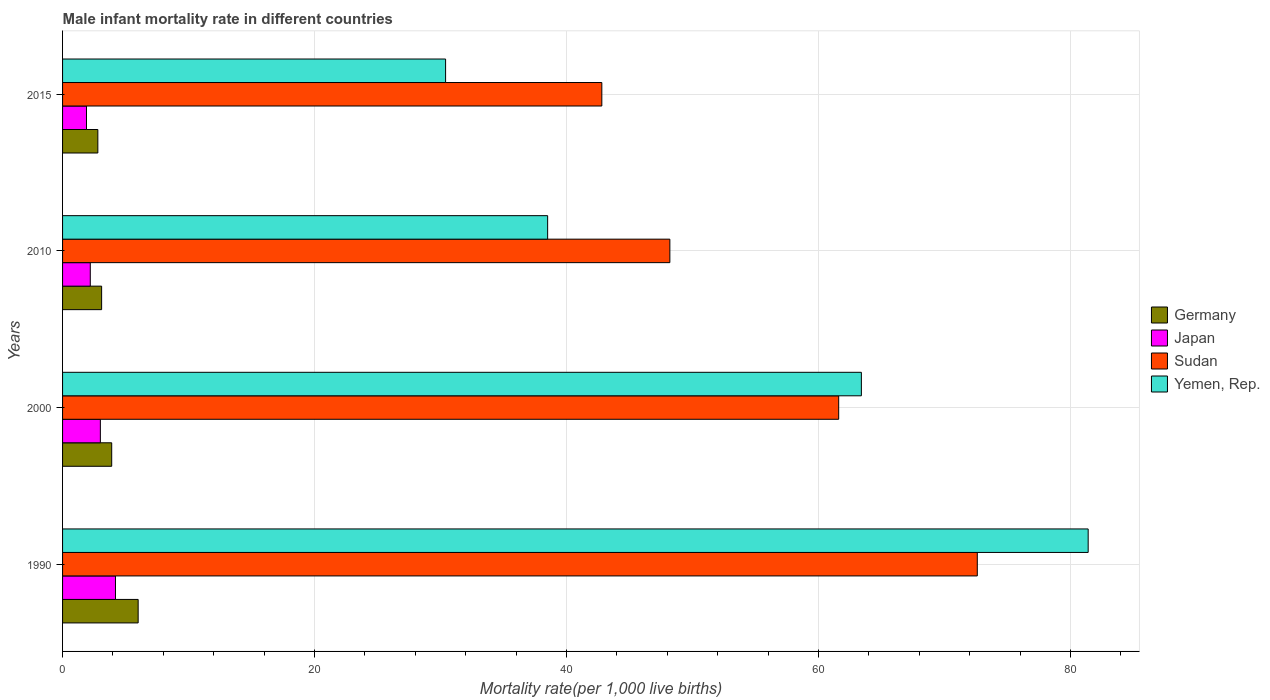How many different coloured bars are there?
Make the answer very short. 4. How many groups of bars are there?
Ensure brevity in your answer.  4. Are the number of bars on each tick of the Y-axis equal?
Provide a short and direct response. Yes. How many bars are there on the 3rd tick from the top?
Keep it short and to the point. 4. What is the label of the 1st group of bars from the top?
Your response must be concise. 2015. In how many cases, is the number of bars for a given year not equal to the number of legend labels?
Your answer should be compact. 0. What is the male infant mortality rate in Japan in 2000?
Make the answer very short. 3. Across all years, what is the maximum male infant mortality rate in Yemen, Rep.?
Provide a succinct answer. 81.4. Across all years, what is the minimum male infant mortality rate in Japan?
Your response must be concise. 1.9. In which year was the male infant mortality rate in Germany minimum?
Offer a terse response. 2015. What is the total male infant mortality rate in Germany in the graph?
Your response must be concise. 15.8. What is the difference between the male infant mortality rate in Yemen, Rep. in 1990 and that in 2015?
Ensure brevity in your answer.  51. What is the difference between the male infant mortality rate in Sudan in 2010 and the male infant mortality rate in Japan in 2015?
Provide a succinct answer. 46.3. What is the average male infant mortality rate in Japan per year?
Keep it short and to the point. 2.83. In the year 2000, what is the difference between the male infant mortality rate in Japan and male infant mortality rate in Yemen, Rep.?
Provide a short and direct response. -60.4. In how many years, is the male infant mortality rate in Yemen, Rep. greater than 36 ?
Your response must be concise. 3. What is the ratio of the male infant mortality rate in Sudan in 2000 to that in 2010?
Provide a short and direct response. 1.28. Is the difference between the male infant mortality rate in Japan in 1990 and 2015 greater than the difference between the male infant mortality rate in Yemen, Rep. in 1990 and 2015?
Give a very brief answer. No. What is the difference between the highest and the second highest male infant mortality rate in Germany?
Provide a short and direct response. 2.1. What is the difference between the highest and the lowest male infant mortality rate in Japan?
Ensure brevity in your answer.  2.3. Is the sum of the male infant mortality rate in Yemen, Rep. in 2010 and 2015 greater than the maximum male infant mortality rate in Japan across all years?
Your answer should be compact. Yes. What does the 1st bar from the top in 2015 represents?
Your answer should be very brief. Yemen, Rep. How many bars are there?
Offer a very short reply. 16. What is the difference between two consecutive major ticks on the X-axis?
Keep it short and to the point. 20. Does the graph contain any zero values?
Your response must be concise. No. Where does the legend appear in the graph?
Your answer should be very brief. Center right. How are the legend labels stacked?
Your response must be concise. Vertical. What is the title of the graph?
Provide a short and direct response. Male infant mortality rate in different countries. What is the label or title of the X-axis?
Your answer should be compact. Mortality rate(per 1,0 live births). What is the label or title of the Y-axis?
Your response must be concise. Years. What is the Mortality rate(per 1,000 live births) in Sudan in 1990?
Offer a very short reply. 72.6. What is the Mortality rate(per 1,000 live births) of Yemen, Rep. in 1990?
Keep it short and to the point. 81.4. What is the Mortality rate(per 1,000 live births) in Japan in 2000?
Your response must be concise. 3. What is the Mortality rate(per 1,000 live births) in Sudan in 2000?
Make the answer very short. 61.6. What is the Mortality rate(per 1,000 live births) of Yemen, Rep. in 2000?
Give a very brief answer. 63.4. What is the Mortality rate(per 1,000 live births) in Japan in 2010?
Make the answer very short. 2.2. What is the Mortality rate(per 1,000 live births) of Sudan in 2010?
Ensure brevity in your answer.  48.2. What is the Mortality rate(per 1,000 live births) in Yemen, Rep. in 2010?
Make the answer very short. 38.5. What is the Mortality rate(per 1,000 live births) in Germany in 2015?
Keep it short and to the point. 2.8. What is the Mortality rate(per 1,000 live births) of Japan in 2015?
Keep it short and to the point. 1.9. What is the Mortality rate(per 1,000 live births) of Sudan in 2015?
Provide a succinct answer. 42.8. What is the Mortality rate(per 1,000 live births) in Yemen, Rep. in 2015?
Offer a very short reply. 30.4. Across all years, what is the maximum Mortality rate(per 1,000 live births) of Japan?
Offer a terse response. 4.2. Across all years, what is the maximum Mortality rate(per 1,000 live births) in Sudan?
Keep it short and to the point. 72.6. Across all years, what is the maximum Mortality rate(per 1,000 live births) of Yemen, Rep.?
Make the answer very short. 81.4. Across all years, what is the minimum Mortality rate(per 1,000 live births) in Germany?
Your answer should be compact. 2.8. Across all years, what is the minimum Mortality rate(per 1,000 live births) of Japan?
Keep it short and to the point. 1.9. Across all years, what is the minimum Mortality rate(per 1,000 live births) of Sudan?
Make the answer very short. 42.8. Across all years, what is the minimum Mortality rate(per 1,000 live births) in Yemen, Rep.?
Provide a succinct answer. 30.4. What is the total Mortality rate(per 1,000 live births) in Japan in the graph?
Ensure brevity in your answer.  11.3. What is the total Mortality rate(per 1,000 live births) of Sudan in the graph?
Offer a terse response. 225.2. What is the total Mortality rate(per 1,000 live births) of Yemen, Rep. in the graph?
Your answer should be compact. 213.7. What is the difference between the Mortality rate(per 1,000 live births) of Sudan in 1990 and that in 2000?
Keep it short and to the point. 11. What is the difference between the Mortality rate(per 1,000 live births) of Japan in 1990 and that in 2010?
Ensure brevity in your answer.  2. What is the difference between the Mortality rate(per 1,000 live births) of Sudan in 1990 and that in 2010?
Offer a very short reply. 24.4. What is the difference between the Mortality rate(per 1,000 live births) in Yemen, Rep. in 1990 and that in 2010?
Your answer should be very brief. 42.9. What is the difference between the Mortality rate(per 1,000 live births) of Sudan in 1990 and that in 2015?
Your response must be concise. 29.8. What is the difference between the Mortality rate(per 1,000 live births) in Germany in 2000 and that in 2010?
Make the answer very short. 0.8. What is the difference between the Mortality rate(per 1,000 live births) in Japan in 2000 and that in 2010?
Provide a succinct answer. 0.8. What is the difference between the Mortality rate(per 1,000 live births) in Yemen, Rep. in 2000 and that in 2010?
Provide a short and direct response. 24.9. What is the difference between the Mortality rate(per 1,000 live births) in Sudan in 2000 and that in 2015?
Give a very brief answer. 18.8. What is the difference between the Mortality rate(per 1,000 live births) in Yemen, Rep. in 2000 and that in 2015?
Make the answer very short. 33. What is the difference between the Mortality rate(per 1,000 live births) of Germany in 1990 and the Mortality rate(per 1,000 live births) of Sudan in 2000?
Your answer should be compact. -55.6. What is the difference between the Mortality rate(per 1,000 live births) of Germany in 1990 and the Mortality rate(per 1,000 live births) of Yemen, Rep. in 2000?
Offer a terse response. -57.4. What is the difference between the Mortality rate(per 1,000 live births) in Japan in 1990 and the Mortality rate(per 1,000 live births) in Sudan in 2000?
Your answer should be very brief. -57.4. What is the difference between the Mortality rate(per 1,000 live births) of Japan in 1990 and the Mortality rate(per 1,000 live births) of Yemen, Rep. in 2000?
Make the answer very short. -59.2. What is the difference between the Mortality rate(per 1,000 live births) of Germany in 1990 and the Mortality rate(per 1,000 live births) of Japan in 2010?
Offer a very short reply. 3.8. What is the difference between the Mortality rate(per 1,000 live births) of Germany in 1990 and the Mortality rate(per 1,000 live births) of Sudan in 2010?
Keep it short and to the point. -42.2. What is the difference between the Mortality rate(per 1,000 live births) in Germany in 1990 and the Mortality rate(per 1,000 live births) in Yemen, Rep. in 2010?
Offer a terse response. -32.5. What is the difference between the Mortality rate(per 1,000 live births) of Japan in 1990 and the Mortality rate(per 1,000 live births) of Sudan in 2010?
Provide a succinct answer. -44. What is the difference between the Mortality rate(per 1,000 live births) in Japan in 1990 and the Mortality rate(per 1,000 live births) in Yemen, Rep. in 2010?
Your answer should be very brief. -34.3. What is the difference between the Mortality rate(per 1,000 live births) in Sudan in 1990 and the Mortality rate(per 1,000 live births) in Yemen, Rep. in 2010?
Your response must be concise. 34.1. What is the difference between the Mortality rate(per 1,000 live births) of Germany in 1990 and the Mortality rate(per 1,000 live births) of Japan in 2015?
Ensure brevity in your answer.  4.1. What is the difference between the Mortality rate(per 1,000 live births) of Germany in 1990 and the Mortality rate(per 1,000 live births) of Sudan in 2015?
Offer a terse response. -36.8. What is the difference between the Mortality rate(per 1,000 live births) of Germany in 1990 and the Mortality rate(per 1,000 live births) of Yemen, Rep. in 2015?
Give a very brief answer. -24.4. What is the difference between the Mortality rate(per 1,000 live births) in Japan in 1990 and the Mortality rate(per 1,000 live births) in Sudan in 2015?
Your answer should be compact. -38.6. What is the difference between the Mortality rate(per 1,000 live births) of Japan in 1990 and the Mortality rate(per 1,000 live births) of Yemen, Rep. in 2015?
Make the answer very short. -26.2. What is the difference between the Mortality rate(per 1,000 live births) in Sudan in 1990 and the Mortality rate(per 1,000 live births) in Yemen, Rep. in 2015?
Make the answer very short. 42.2. What is the difference between the Mortality rate(per 1,000 live births) of Germany in 2000 and the Mortality rate(per 1,000 live births) of Sudan in 2010?
Give a very brief answer. -44.3. What is the difference between the Mortality rate(per 1,000 live births) in Germany in 2000 and the Mortality rate(per 1,000 live births) in Yemen, Rep. in 2010?
Your answer should be very brief. -34.6. What is the difference between the Mortality rate(per 1,000 live births) of Japan in 2000 and the Mortality rate(per 1,000 live births) of Sudan in 2010?
Provide a succinct answer. -45.2. What is the difference between the Mortality rate(per 1,000 live births) in Japan in 2000 and the Mortality rate(per 1,000 live births) in Yemen, Rep. in 2010?
Your answer should be compact. -35.5. What is the difference between the Mortality rate(per 1,000 live births) of Sudan in 2000 and the Mortality rate(per 1,000 live births) of Yemen, Rep. in 2010?
Your answer should be very brief. 23.1. What is the difference between the Mortality rate(per 1,000 live births) in Germany in 2000 and the Mortality rate(per 1,000 live births) in Japan in 2015?
Make the answer very short. 2. What is the difference between the Mortality rate(per 1,000 live births) in Germany in 2000 and the Mortality rate(per 1,000 live births) in Sudan in 2015?
Offer a terse response. -38.9. What is the difference between the Mortality rate(per 1,000 live births) in Germany in 2000 and the Mortality rate(per 1,000 live births) in Yemen, Rep. in 2015?
Keep it short and to the point. -26.5. What is the difference between the Mortality rate(per 1,000 live births) of Japan in 2000 and the Mortality rate(per 1,000 live births) of Sudan in 2015?
Make the answer very short. -39.8. What is the difference between the Mortality rate(per 1,000 live births) of Japan in 2000 and the Mortality rate(per 1,000 live births) of Yemen, Rep. in 2015?
Offer a very short reply. -27.4. What is the difference between the Mortality rate(per 1,000 live births) of Sudan in 2000 and the Mortality rate(per 1,000 live births) of Yemen, Rep. in 2015?
Your answer should be compact. 31.2. What is the difference between the Mortality rate(per 1,000 live births) in Germany in 2010 and the Mortality rate(per 1,000 live births) in Sudan in 2015?
Provide a succinct answer. -39.7. What is the difference between the Mortality rate(per 1,000 live births) of Germany in 2010 and the Mortality rate(per 1,000 live births) of Yemen, Rep. in 2015?
Keep it short and to the point. -27.3. What is the difference between the Mortality rate(per 1,000 live births) of Japan in 2010 and the Mortality rate(per 1,000 live births) of Sudan in 2015?
Keep it short and to the point. -40.6. What is the difference between the Mortality rate(per 1,000 live births) in Japan in 2010 and the Mortality rate(per 1,000 live births) in Yemen, Rep. in 2015?
Give a very brief answer. -28.2. What is the average Mortality rate(per 1,000 live births) of Germany per year?
Offer a terse response. 3.95. What is the average Mortality rate(per 1,000 live births) of Japan per year?
Give a very brief answer. 2.83. What is the average Mortality rate(per 1,000 live births) in Sudan per year?
Give a very brief answer. 56.3. What is the average Mortality rate(per 1,000 live births) in Yemen, Rep. per year?
Ensure brevity in your answer.  53.42. In the year 1990, what is the difference between the Mortality rate(per 1,000 live births) of Germany and Mortality rate(per 1,000 live births) of Japan?
Your response must be concise. 1.8. In the year 1990, what is the difference between the Mortality rate(per 1,000 live births) of Germany and Mortality rate(per 1,000 live births) of Sudan?
Your answer should be compact. -66.6. In the year 1990, what is the difference between the Mortality rate(per 1,000 live births) in Germany and Mortality rate(per 1,000 live births) in Yemen, Rep.?
Provide a short and direct response. -75.4. In the year 1990, what is the difference between the Mortality rate(per 1,000 live births) of Japan and Mortality rate(per 1,000 live births) of Sudan?
Provide a succinct answer. -68.4. In the year 1990, what is the difference between the Mortality rate(per 1,000 live births) of Japan and Mortality rate(per 1,000 live births) of Yemen, Rep.?
Your answer should be very brief. -77.2. In the year 2000, what is the difference between the Mortality rate(per 1,000 live births) in Germany and Mortality rate(per 1,000 live births) in Japan?
Keep it short and to the point. 0.9. In the year 2000, what is the difference between the Mortality rate(per 1,000 live births) in Germany and Mortality rate(per 1,000 live births) in Sudan?
Your answer should be very brief. -57.7. In the year 2000, what is the difference between the Mortality rate(per 1,000 live births) in Germany and Mortality rate(per 1,000 live births) in Yemen, Rep.?
Give a very brief answer. -59.5. In the year 2000, what is the difference between the Mortality rate(per 1,000 live births) in Japan and Mortality rate(per 1,000 live births) in Sudan?
Give a very brief answer. -58.6. In the year 2000, what is the difference between the Mortality rate(per 1,000 live births) in Japan and Mortality rate(per 1,000 live births) in Yemen, Rep.?
Make the answer very short. -60.4. In the year 2000, what is the difference between the Mortality rate(per 1,000 live births) of Sudan and Mortality rate(per 1,000 live births) of Yemen, Rep.?
Your answer should be compact. -1.8. In the year 2010, what is the difference between the Mortality rate(per 1,000 live births) in Germany and Mortality rate(per 1,000 live births) in Sudan?
Offer a very short reply. -45.1. In the year 2010, what is the difference between the Mortality rate(per 1,000 live births) of Germany and Mortality rate(per 1,000 live births) of Yemen, Rep.?
Your answer should be compact. -35.4. In the year 2010, what is the difference between the Mortality rate(per 1,000 live births) of Japan and Mortality rate(per 1,000 live births) of Sudan?
Provide a succinct answer. -46. In the year 2010, what is the difference between the Mortality rate(per 1,000 live births) of Japan and Mortality rate(per 1,000 live births) of Yemen, Rep.?
Make the answer very short. -36.3. In the year 2010, what is the difference between the Mortality rate(per 1,000 live births) of Sudan and Mortality rate(per 1,000 live births) of Yemen, Rep.?
Offer a terse response. 9.7. In the year 2015, what is the difference between the Mortality rate(per 1,000 live births) in Germany and Mortality rate(per 1,000 live births) in Japan?
Give a very brief answer. 0.9. In the year 2015, what is the difference between the Mortality rate(per 1,000 live births) of Germany and Mortality rate(per 1,000 live births) of Yemen, Rep.?
Provide a succinct answer. -27.6. In the year 2015, what is the difference between the Mortality rate(per 1,000 live births) in Japan and Mortality rate(per 1,000 live births) in Sudan?
Provide a short and direct response. -40.9. In the year 2015, what is the difference between the Mortality rate(per 1,000 live births) of Japan and Mortality rate(per 1,000 live births) of Yemen, Rep.?
Your answer should be compact. -28.5. In the year 2015, what is the difference between the Mortality rate(per 1,000 live births) of Sudan and Mortality rate(per 1,000 live births) of Yemen, Rep.?
Provide a short and direct response. 12.4. What is the ratio of the Mortality rate(per 1,000 live births) in Germany in 1990 to that in 2000?
Your answer should be very brief. 1.54. What is the ratio of the Mortality rate(per 1,000 live births) in Sudan in 1990 to that in 2000?
Your answer should be very brief. 1.18. What is the ratio of the Mortality rate(per 1,000 live births) in Yemen, Rep. in 1990 to that in 2000?
Offer a very short reply. 1.28. What is the ratio of the Mortality rate(per 1,000 live births) of Germany in 1990 to that in 2010?
Make the answer very short. 1.94. What is the ratio of the Mortality rate(per 1,000 live births) in Japan in 1990 to that in 2010?
Keep it short and to the point. 1.91. What is the ratio of the Mortality rate(per 1,000 live births) of Sudan in 1990 to that in 2010?
Your response must be concise. 1.51. What is the ratio of the Mortality rate(per 1,000 live births) of Yemen, Rep. in 1990 to that in 2010?
Keep it short and to the point. 2.11. What is the ratio of the Mortality rate(per 1,000 live births) in Germany in 1990 to that in 2015?
Offer a very short reply. 2.14. What is the ratio of the Mortality rate(per 1,000 live births) in Japan in 1990 to that in 2015?
Ensure brevity in your answer.  2.21. What is the ratio of the Mortality rate(per 1,000 live births) in Sudan in 1990 to that in 2015?
Provide a short and direct response. 1.7. What is the ratio of the Mortality rate(per 1,000 live births) in Yemen, Rep. in 1990 to that in 2015?
Provide a succinct answer. 2.68. What is the ratio of the Mortality rate(per 1,000 live births) in Germany in 2000 to that in 2010?
Provide a short and direct response. 1.26. What is the ratio of the Mortality rate(per 1,000 live births) in Japan in 2000 to that in 2010?
Your answer should be compact. 1.36. What is the ratio of the Mortality rate(per 1,000 live births) in Sudan in 2000 to that in 2010?
Your response must be concise. 1.28. What is the ratio of the Mortality rate(per 1,000 live births) in Yemen, Rep. in 2000 to that in 2010?
Your answer should be compact. 1.65. What is the ratio of the Mortality rate(per 1,000 live births) of Germany in 2000 to that in 2015?
Your answer should be compact. 1.39. What is the ratio of the Mortality rate(per 1,000 live births) of Japan in 2000 to that in 2015?
Offer a very short reply. 1.58. What is the ratio of the Mortality rate(per 1,000 live births) of Sudan in 2000 to that in 2015?
Your answer should be compact. 1.44. What is the ratio of the Mortality rate(per 1,000 live births) of Yemen, Rep. in 2000 to that in 2015?
Offer a very short reply. 2.09. What is the ratio of the Mortality rate(per 1,000 live births) in Germany in 2010 to that in 2015?
Your answer should be very brief. 1.11. What is the ratio of the Mortality rate(per 1,000 live births) in Japan in 2010 to that in 2015?
Ensure brevity in your answer.  1.16. What is the ratio of the Mortality rate(per 1,000 live births) in Sudan in 2010 to that in 2015?
Provide a short and direct response. 1.13. What is the ratio of the Mortality rate(per 1,000 live births) in Yemen, Rep. in 2010 to that in 2015?
Offer a terse response. 1.27. What is the difference between the highest and the second highest Mortality rate(per 1,000 live births) of Germany?
Provide a short and direct response. 2.1. What is the difference between the highest and the second highest Mortality rate(per 1,000 live births) in Japan?
Provide a succinct answer. 1.2. What is the difference between the highest and the lowest Mortality rate(per 1,000 live births) of Germany?
Your response must be concise. 3.2. What is the difference between the highest and the lowest Mortality rate(per 1,000 live births) in Japan?
Make the answer very short. 2.3. What is the difference between the highest and the lowest Mortality rate(per 1,000 live births) in Sudan?
Offer a terse response. 29.8. 